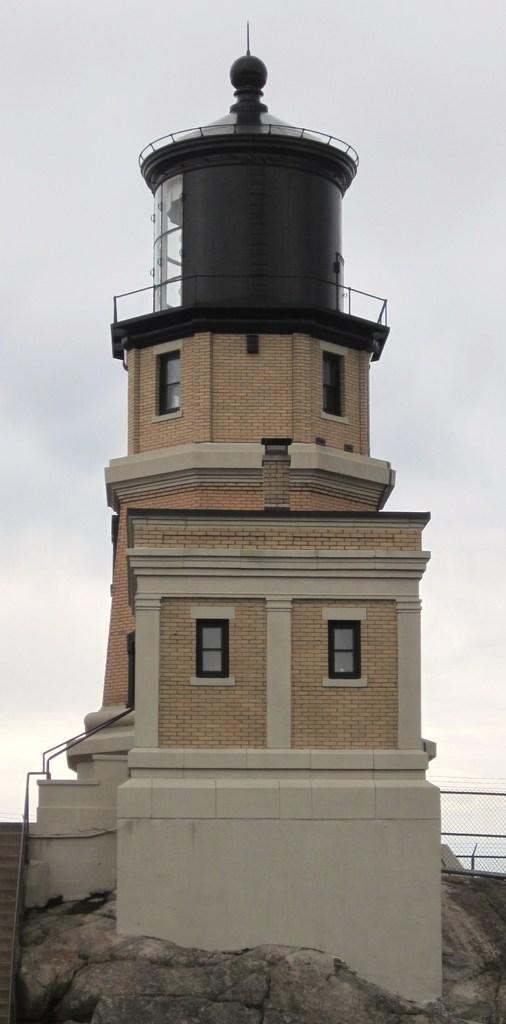What type of structure is in the image? There is a split rock lighthouse in the image. Where is the lighthouse located? The lighthouse is on a path. What can be seen in the background of the image? There is a sky visible in the image. What is behind the lighthouse? There is a fence behind the lighthouse. How does the toothbrush show respect in the image? There is no toothbrush present in the image, and therefore it cannot show respect. 